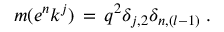Convert formula to latex. <formula><loc_0><loc_0><loc_500><loc_500>m ( e ^ { n } k ^ { j } ) \, = \, q ^ { 2 } \delta _ { j , 2 } \delta _ { n , ( l - 1 ) } \, .</formula> 